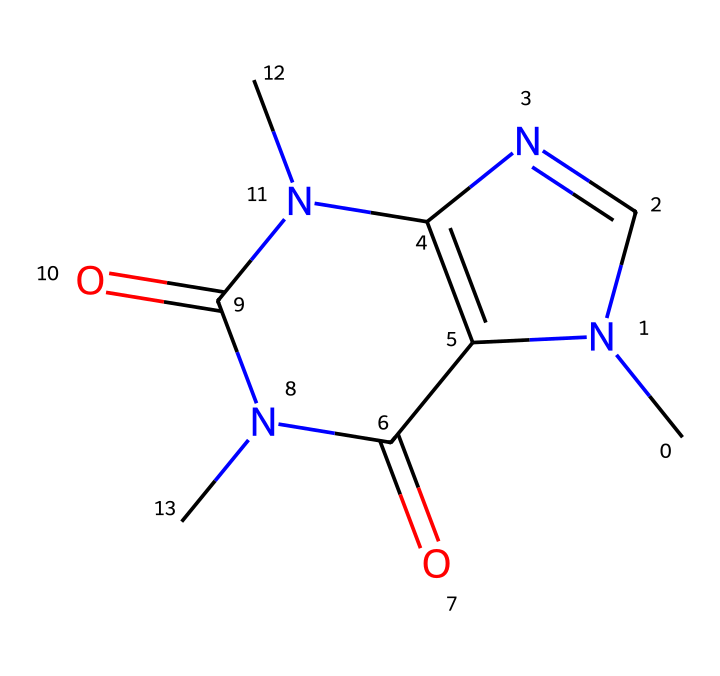What is the molecular formula of caffeine? To determine the molecular formula, we can analyze the provided SMILES. From the structure, we can count the number of each atom: 8 carbon (C), 10 hydrogen (H), 4 nitrogen (N), and 2 oxygen (O). Therefore, the molecular formula is C8H10N4O2.
Answer: C8H10N4O2 How many nitrogen atoms are present in caffeine? By examining the SMILES notation, we can identify the nitrogen atoms in the structure. There are four nitrogen atoms indicated in the composition.
Answer: 4 What type of molecular configuration does caffeine have? The structure depicted shows multiple rings and is categorized as a purine alkaloid due to its fused bicyclic structure containing nitrogen atoms. This classification is based on its comprehensive ring layout and presence of nitrogen.
Answer: purine alkaloid Which elements are present in the caffeine structure? By analyzing the SMILES representation, we can see that caffeine contains carbon, hydrogen, nitrogen, and oxygen atoms. The presence of these elements is fundamental to its chemical identity and properties.
Answer: carbon, hydrogen, nitrogen, oxygen What functional groups are identified in caffeine? Reviewing the structure, caffeine has carbonyl functional groups (C=O) and amine functional groups (N). The carbonyls are recognized at specific points where double bonds to oxygen appear, while nitrogen atoms follow the amine classification.
Answer: carbonyl, amine What is the total number of carbon atoms in the caffeine molecule? From the SMILES structure, counting the carbon atoms reveals there are eight carbon atoms present in caffeine, a key component of its molecular structure.
Answer: 8 